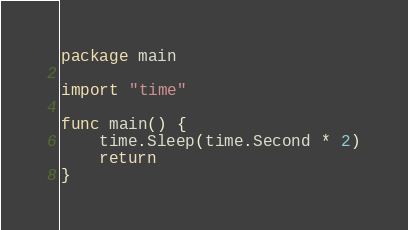<code> <loc_0><loc_0><loc_500><loc_500><_Go_>package main

import "time"

func main() {
	time.Sleep(time.Second * 2)
	return
}

</code> 